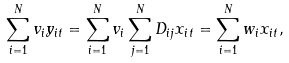Convert formula to latex. <formula><loc_0><loc_0><loc_500><loc_500>\sum _ { i = 1 } ^ { N } v _ { i } y _ { i t } = \sum _ { i = 1 } ^ { N } v _ { i } \sum _ { j = 1 } ^ { N } D _ { i j } x _ { i t } = \sum _ { i = 1 } ^ { N } w _ { i } x _ { i t } ,</formula> 